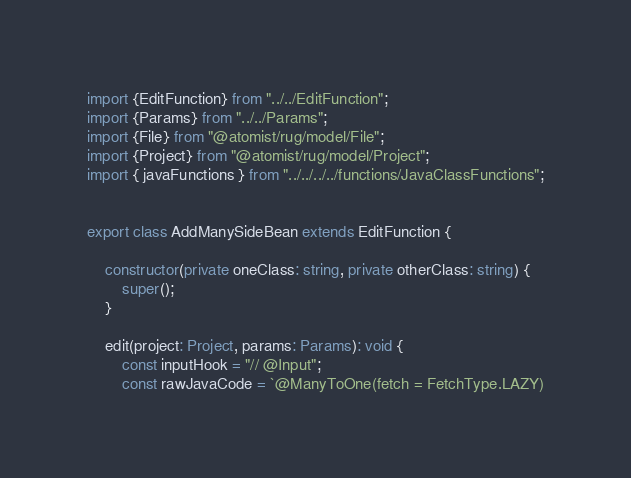Convert code to text. <code><loc_0><loc_0><loc_500><loc_500><_TypeScript_>import {EditFunction} from "../../EditFunction";
import {Params} from "../../Params";
import {File} from "@atomist/rug/model/File";
import {Project} from "@atomist/rug/model/Project";
import { javaFunctions } from "../../../../functions/JavaClassFunctions";


export class AddManySideBean extends EditFunction {

    constructor(private oneClass: string, private otherClass: string) {
        super();
    }

    edit(project: Project, params: Params): void {
        const inputHook = "// @Input";
        const rawJavaCode = `@ManyToOne(fetch = FetchType.LAZY)</code> 